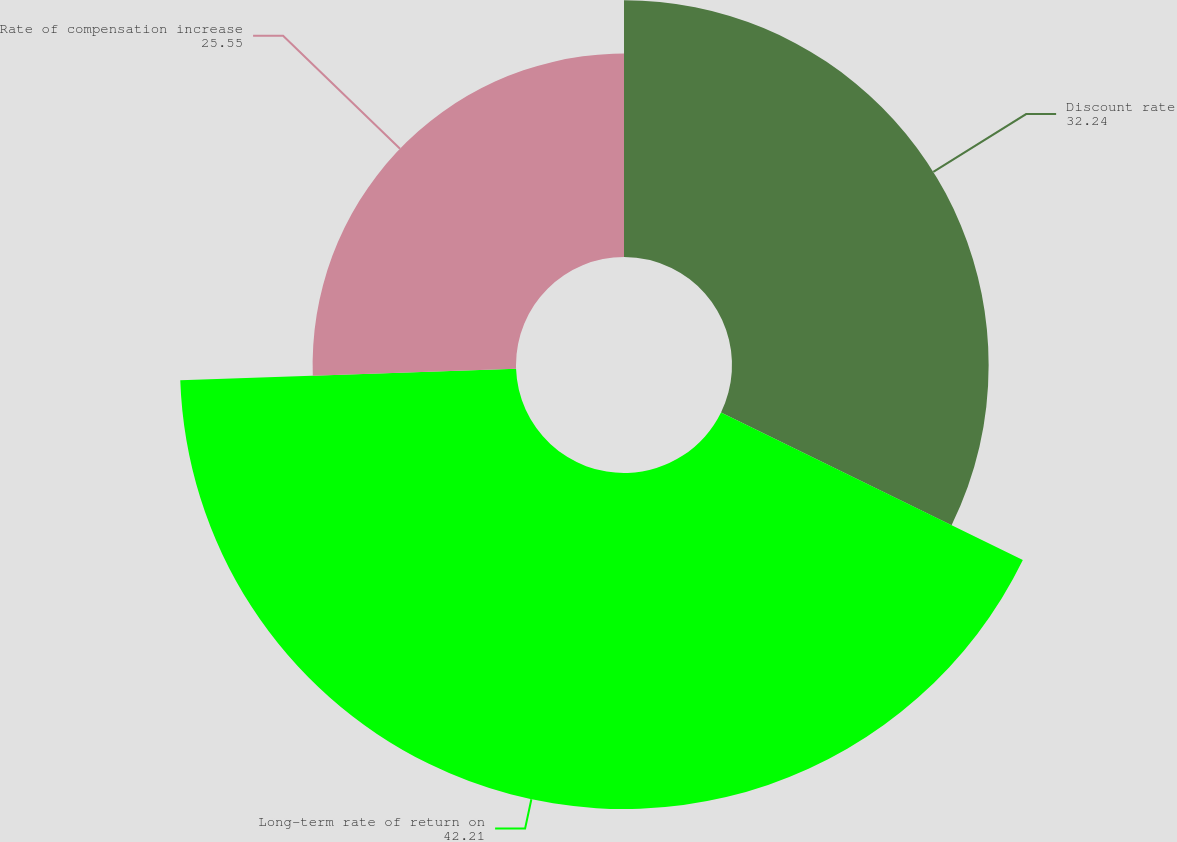<chart> <loc_0><loc_0><loc_500><loc_500><pie_chart><fcel>Discount rate<fcel>Long-term rate of return on<fcel>Rate of compensation increase<nl><fcel>32.24%<fcel>42.21%<fcel>25.55%<nl></chart> 